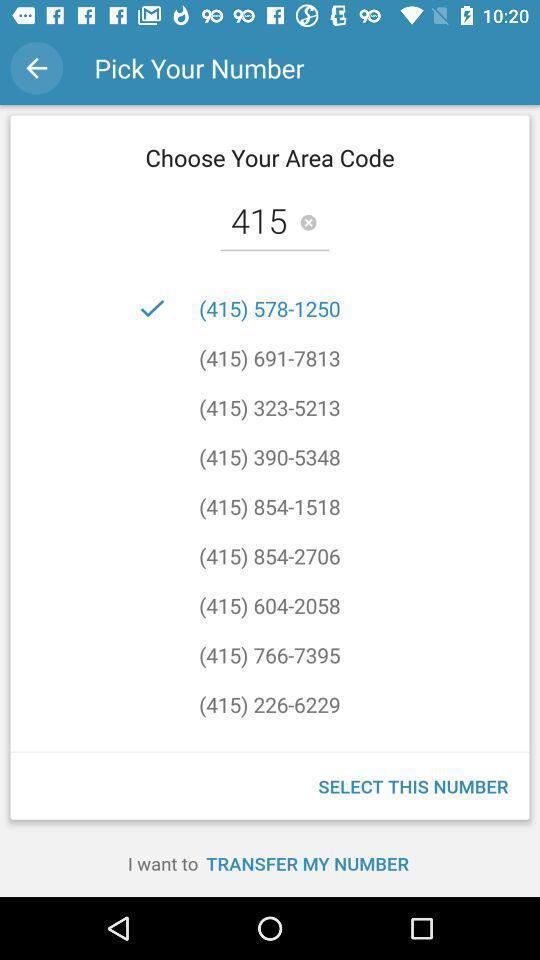Provide a description of this screenshot. Page for choosing a phone number for an app. 